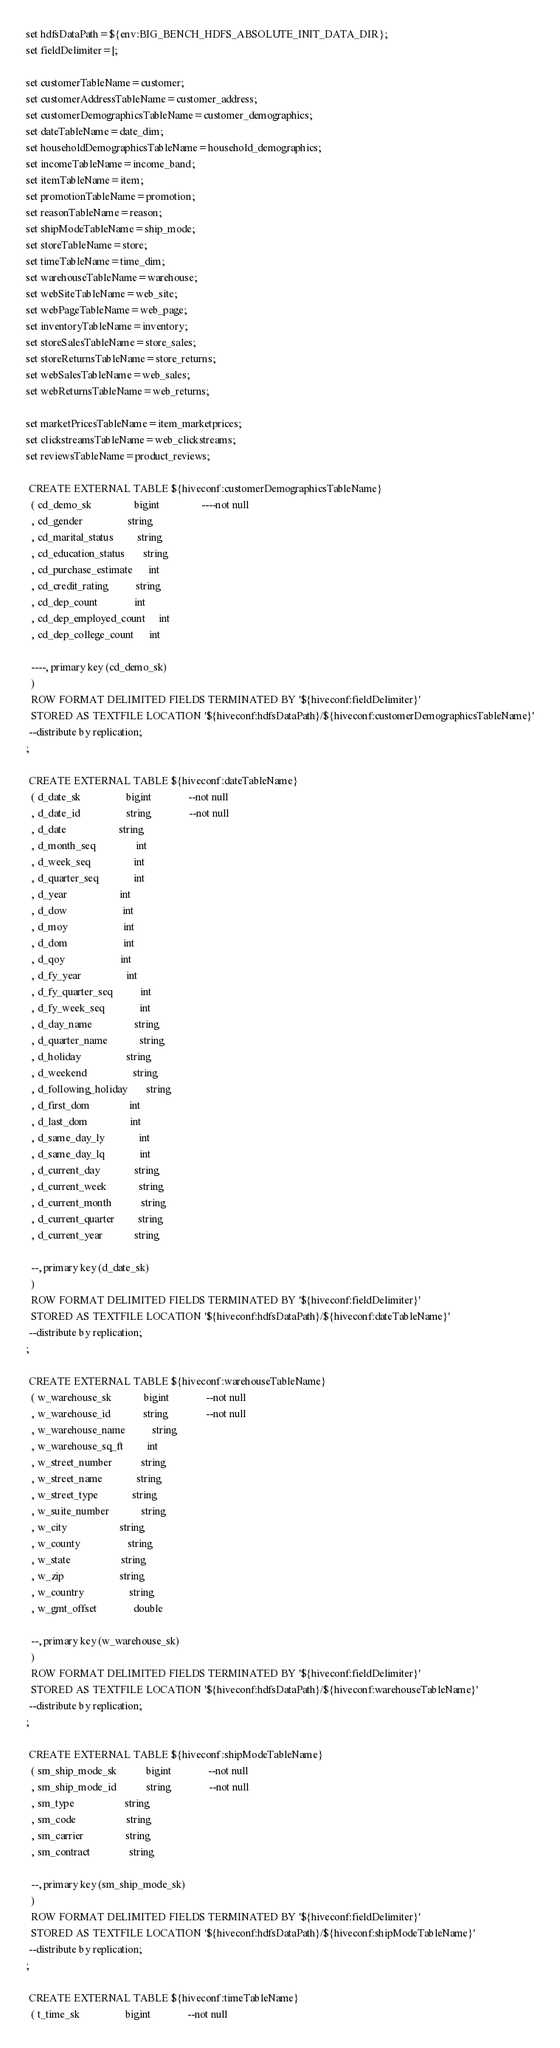Convert code to text. <code><loc_0><loc_0><loc_500><loc_500><_SQL_>set hdfsDataPath=${env:BIG_BENCH_HDFS_ABSOLUTE_INIT_DATA_DIR};
set fieldDelimiter=|;

set customerTableName=customer;
set customerAddressTableName=customer_address;
set customerDemographicsTableName=customer_demographics;
set dateTableName=date_dim;
set householdDemographicsTableName=household_demographics;
set incomeTableName=income_band;
set itemTableName=item;
set promotionTableName=promotion;
set reasonTableName=reason;
set shipModeTableName=ship_mode;
set storeTableName=store;
set timeTableName=time_dim;
set warehouseTableName=warehouse;
set webSiteTableName=web_site;
set webPageTableName=web_page;
set inventoryTableName=inventory;
set storeSalesTableName=store_sales;
set storeReturnsTableName=store_returns;
set webSalesTableName=web_sales;
set webReturnsTableName=web_returns;

set marketPricesTableName=item_marketprices;
set clickstreamsTableName=web_clickstreams;
set reviewsTableName=product_reviews;

 CREATE EXTERNAL TABLE ${hiveconf:customerDemographicsTableName}
  ( cd_demo_sk                bigint                ----not null
  , cd_gender                 string
  , cd_marital_status         string
  , cd_education_status       string
  , cd_purchase_estimate      int
  , cd_credit_rating          string
  , cd_dep_count              int
  , cd_dep_employed_count     int
  , cd_dep_college_count      int

  ----, primary key (cd_demo_sk)
  )
  ROW FORMAT DELIMITED FIELDS TERMINATED BY '${hiveconf:fieldDelimiter}'
  STORED AS TEXTFILE LOCATION '${hiveconf:hdfsDataPath}/${hiveconf:customerDemographicsTableName}'
 --distribute by replication;
;

 CREATE EXTERNAL TABLE ${hiveconf:dateTableName}
  ( d_date_sk                 bigint              --not null
  , d_date_id                 string              --not null
  , d_date                    string
  , d_month_seq               int
  , d_week_seq                int
  , d_quarter_seq             int
  , d_year                    int
  , d_dow                     int
  , d_moy                     int
  , d_dom                     int
  , d_qoy                     int
  , d_fy_year                 int
  , d_fy_quarter_seq          int
  , d_fy_week_seq             int
  , d_day_name                string
  , d_quarter_name            string
  , d_holiday                 string
  , d_weekend                 string
  , d_following_holiday       string
  , d_first_dom               int
  , d_last_dom                int
  , d_same_day_ly             int
  , d_same_day_lq             int
  , d_current_day             string
  , d_current_week            string
  , d_current_month           string
  , d_current_quarter         string
  , d_current_year            string

  --, primary key (d_date_sk)
  )
  ROW FORMAT DELIMITED FIELDS TERMINATED BY '${hiveconf:fieldDelimiter}'
  STORED AS TEXTFILE LOCATION '${hiveconf:hdfsDataPath}/${hiveconf:dateTableName}'
 --distribute by replication;
;

 CREATE EXTERNAL TABLE ${hiveconf:warehouseTableName}
  ( w_warehouse_sk            bigint              --not null
  , w_warehouse_id            string              --not null
  , w_warehouse_name          string
  , w_warehouse_sq_ft         int
  , w_street_number           string
  , w_street_name             string
  , w_street_type             string
  , w_suite_number            string
  , w_city                    string
  , w_county                  string
  , w_state                   string
  , w_zip                     string
  , w_country                 string
  , w_gmt_offset              double

  --, primary key (w_warehouse_sk)
  )
  ROW FORMAT DELIMITED FIELDS TERMINATED BY '${hiveconf:fieldDelimiter}'
  STORED AS TEXTFILE LOCATION '${hiveconf:hdfsDataPath}/${hiveconf:warehouseTableName}'
 --distribute by replication;
;

 CREATE EXTERNAL TABLE ${hiveconf:shipModeTableName}
  ( sm_ship_mode_sk           bigint              --not null
  , sm_ship_mode_id           string              --not null
  , sm_type                   string
  , sm_code                   string
  , sm_carrier                string
  , sm_contract               string

  --, primary key (sm_ship_mode_sk)
  )
  ROW FORMAT DELIMITED FIELDS TERMINATED BY '${hiveconf:fieldDelimiter}'
  STORED AS TEXTFILE LOCATION '${hiveconf:hdfsDataPath}/${hiveconf:shipModeTableName}'
 --distribute by replication;
;

 CREATE EXTERNAL TABLE ${hiveconf:timeTableName}
  ( t_time_sk                 bigint              --not null</code> 